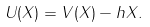<formula> <loc_0><loc_0><loc_500><loc_500>U ( X ) = V ( X ) - h X .</formula> 